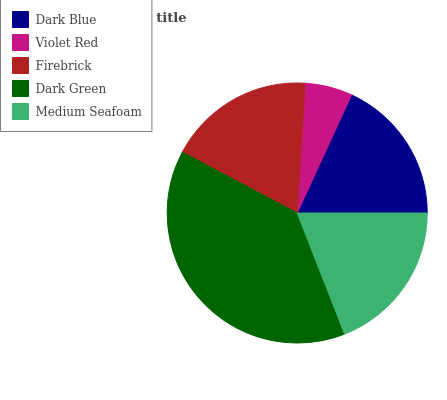Is Violet Red the minimum?
Answer yes or no. Yes. Is Dark Green the maximum?
Answer yes or no. Yes. Is Firebrick the minimum?
Answer yes or no. No. Is Firebrick the maximum?
Answer yes or no. No. Is Firebrick greater than Violet Red?
Answer yes or no. Yes. Is Violet Red less than Firebrick?
Answer yes or no. Yes. Is Violet Red greater than Firebrick?
Answer yes or no. No. Is Firebrick less than Violet Red?
Answer yes or no. No. Is Firebrick the high median?
Answer yes or no. Yes. Is Firebrick the low median?
Answer yes or no. Yes. Is Violet Red the high median?
Answer yes or no. No. Is Medium Seafoam the low median?
Answer yes or no. No. 